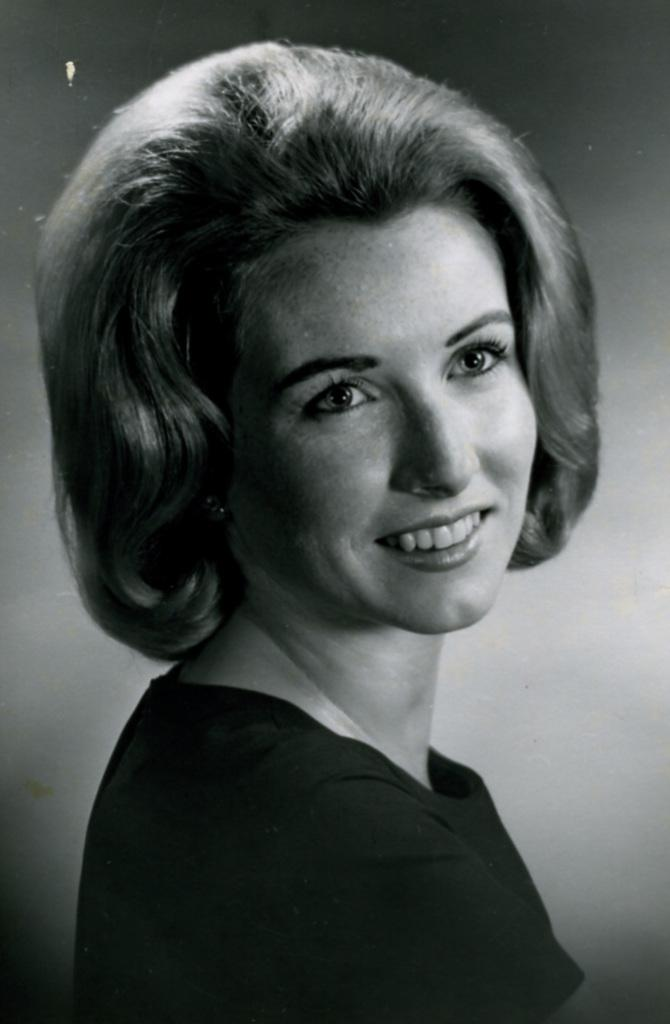What is the color scheme of the image? The image is black and white. Who is present in the image? There is a lady in the image. What is the lady doing in the image? The lady is smiling. What can be seen in the background of the image? There is a wall in the background of the image. How many beads are hanging from the lady's neck in the image? There are no beads visible in the image. What type of oil can be seen dripping from the wall in the image? There is no oil present in the image; it is a black and white image of a lady smiling with a wall in the background. 